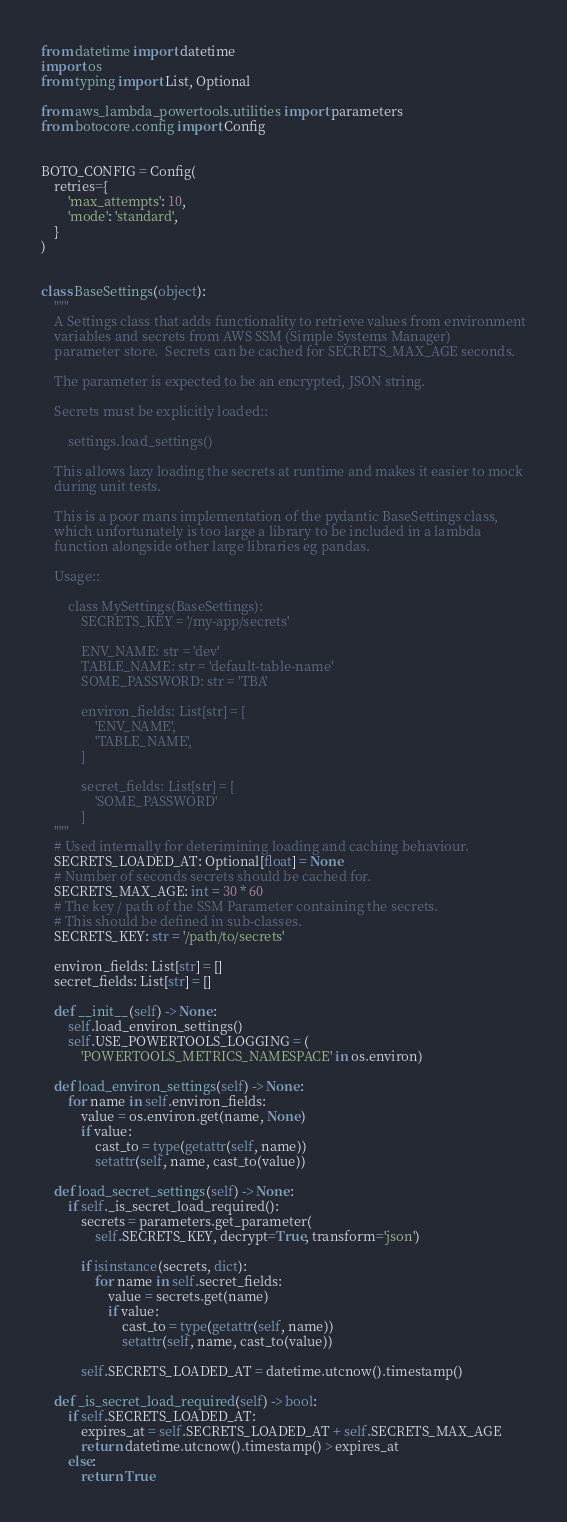<code> <loc_0><loc_0><loc_500><loc_500><_Python_>from datetime import datetime
import os
from typing import List, Optional

from aws_lambda_powertools.utilities import parameters
from botocore.config import Config


BOTO_CONFIG = Config(
    retries={
        'max_attempts': 10,
        'mode': 'standard',
    }
)


class BaseSettings(object):
    """
    A Settings class that adds functionality to retrieve values from environment
    variables and secrets from AWS SSM (Simple Systems Manager)
    parameter store.  Secrets can be cached for SECRETS_MAX_AGE seconds.

    The parameter is expected to be an encrypted, JSON string.

    Secrets must be explicitly loaded::

        settings.load_settings()

    This allows lazy loading the secrets at runtime and makes it easier to mock
    during unit tests.

    This is a poor mans implementation of the pydantic BaseSettings class,
    which unfortunately is too large a library to be included in a lambda
    function alongside other large libraries eg pandas.

    Usage::

        class MySettings(BaseSettings):
            SECRETS_KEY = '/my-app/secrets'

            ENV_NAME: str = 'dev'
            TABLE_NAME: str = 'default-table-name'
            SOME_PASSWORD: str = 'TBA'

            environ_fields: List[str] = [
                'ENV_NAME',
                'TABLE_NAME',
            ]

            secret_fields: List[str] = [
                'SOME_PASSWORD'
            ]
    """
    # Used internally for deterimining loading and caching behaviour.
    SECRETS_LOADED_AT: Optional[float] = None
    # Number of seconds secrets should be cached for.
    SECRETS_MAX_AGE: int = 30 * 60
    # The key / path of the SSM Parameter containing the secrets.
    # This should be defined in sub-classes.
    SECRETS_KEY: str = '/path/to/secrets'

    environ_fields: List[str] = []
    secret_fields: List[str] = []

    def __init__(self) -> None:
        self.load_environ_settings()
        self.USE_POWERTOOLS_LOGGING = (
            'POWERTOOLS_METRICS_NAMESPACE' in os.environ)

    def load_environ_settings(self) -> None:
        for name in self.environ_fields:
            value = os.environ.get(name, None)
            if value:
                cast_to = type(getattr(self, name))
                setattr(self, name, cast_to(value))

    def load_secret_settings(self) -> None:
        if self._is_secret_load_required():
            secrets = parameters.get_parameter(
                self.SECRETS_KEY, decrypt=True, transform='json')

            if isinstance(secrets, dict):
                for name in self.secret_fields:
                    value = secrets.get(name)
                    if value:
                        cast_to = type(getattr(self, name))
                        setattr(self, name, cast_to(value))

            self.SECRETS_LOADED_AT = datetime.utcnow().timestamp()

    def _is_secret_load_required(self) -> bool:
        if self.SECRETS_LOADED_AT:
            expires_at = self.SECRETS_LOADED_AT + self.SECRETS_MAX_AGE
            return datetime.utcnow().timestamp() > expires_at
        else:
            return True
</code> 